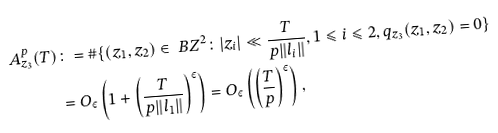<formula> <loc_0><loc_0><loc_500><loc_500>A _ { z _ { 3 } } ^ { p } ( T ) & \colon = \# \{ ( z _ { 1 } , z _ { 2 } ) \in \ B Z ^ { 2 } \colon | z _ { i } | \ll \frac { T } { p \| l _ { i } \| } , 1 \leqslant i \leqslant 2 , q _ { z _ { 3 } } ( z _ { 1 } , z _ { 2 } ) = 0 \} \\ & = O _ { \varepsilon } \left ( 1 + \left ( \frac { T } { p \| l _ { 1 } \| } \right ) ^ { \varepsilon } \right ) = O _ { \varepsilon } \left ( \left ( \frac { T } { p } \right ) ^ { \varepsilon } \right ) ,</formula> 